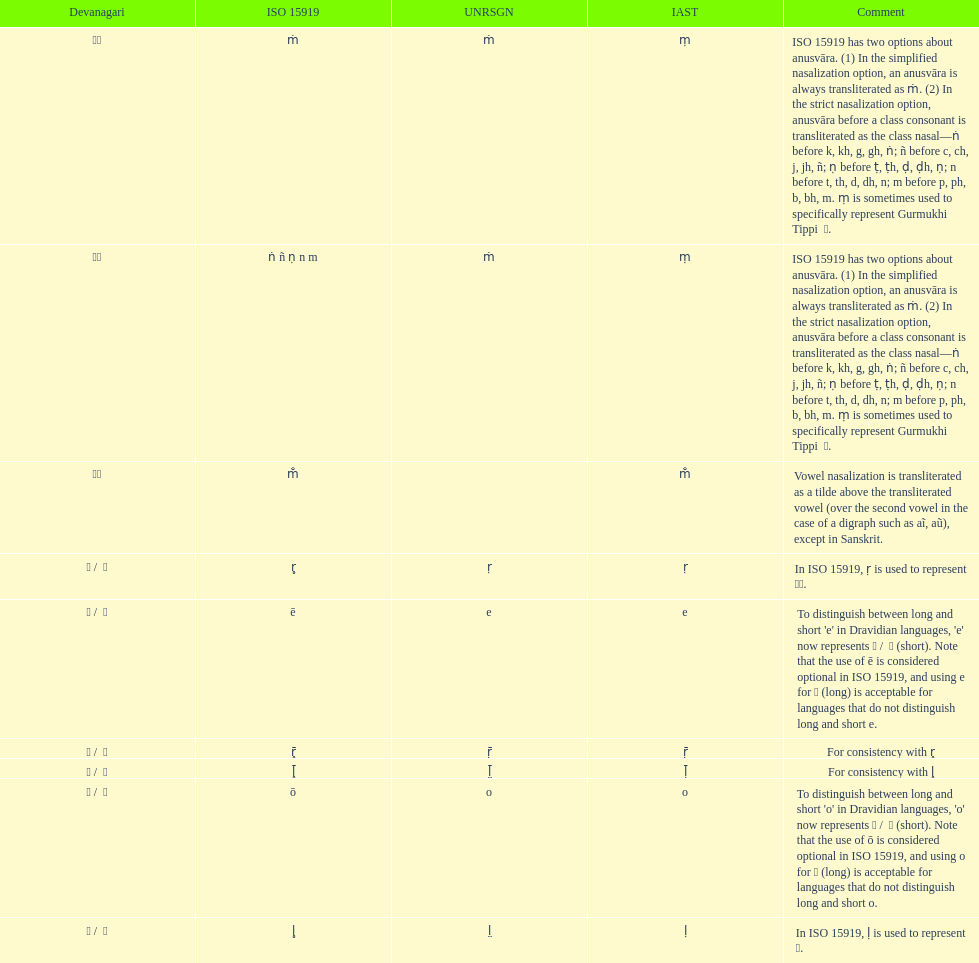What is listed previous to in iso 15919, &#7735; is used to represent &#2355;. under comments? For consistency with r̥. 